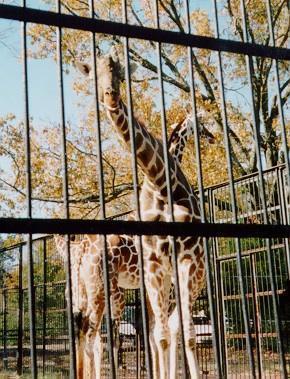How many giraffes are there?
Give a very brief answer. 2. How many giraffes are there?
Give a very brief answer. 2. How many giraffes are in the picture?
Give a very brief answer. 3. How many people can be seen?
Give a very brief answer. 0. 